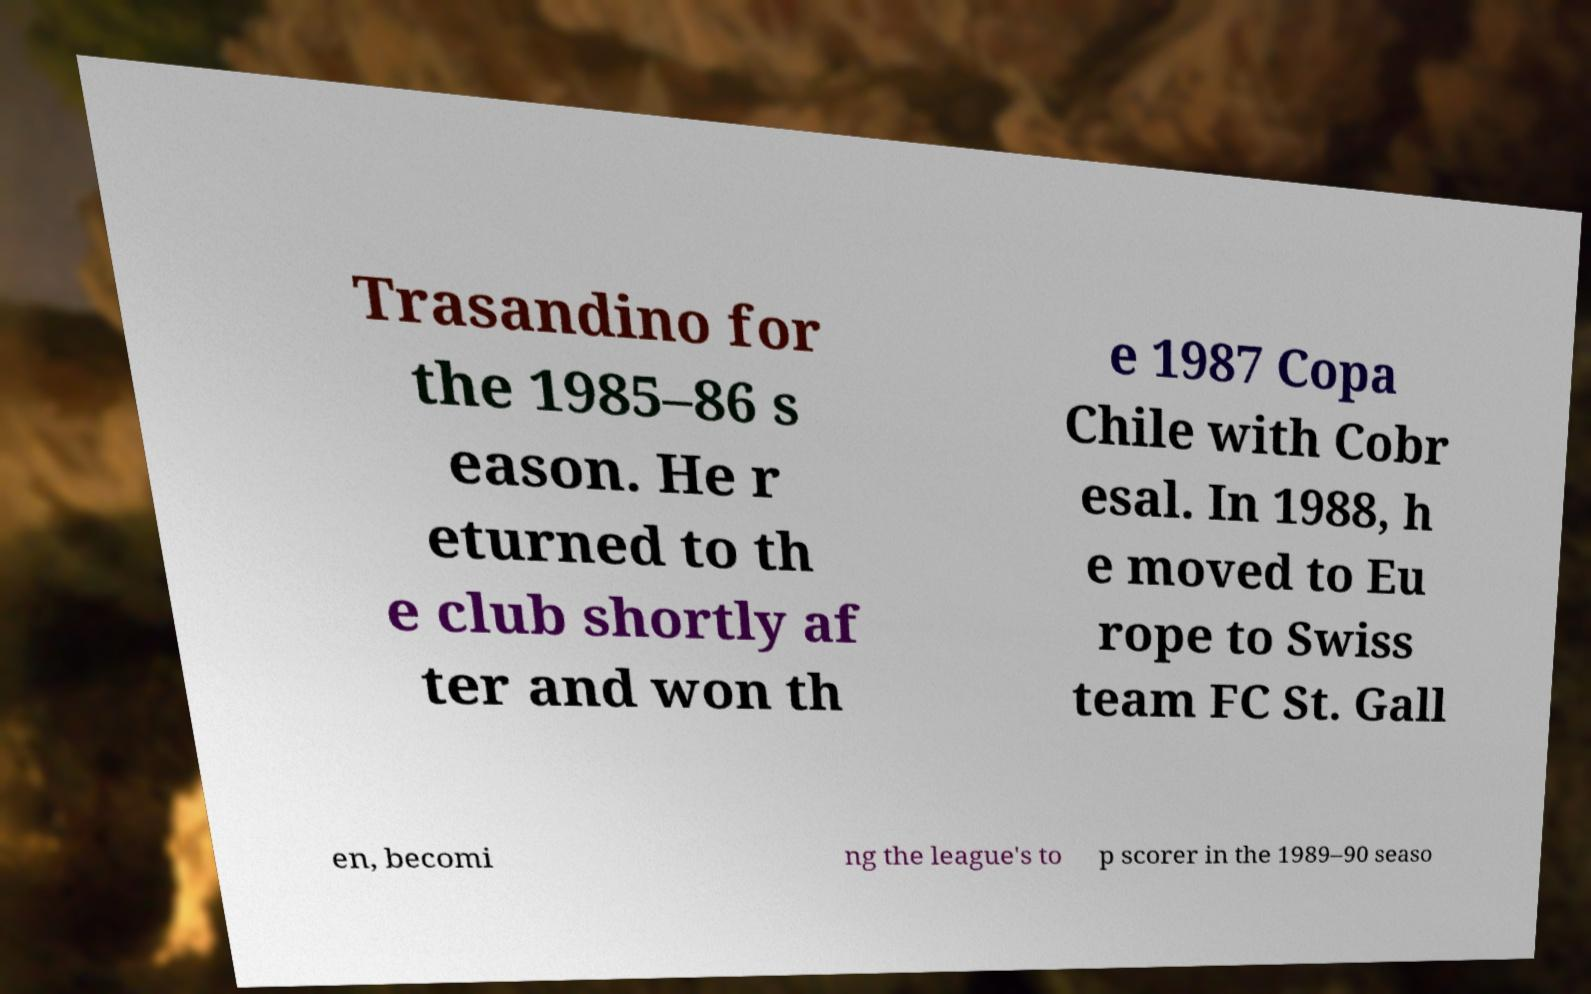Could you assist in decoding the text presented in this image and type it out clearly? Trasandino for the 1985–86 s eason. He r eturned to th e club shortly af ter and won th e 1987 Copa Chile with Cobr esal. In 1988, h e moved to Eu rope to Swiss team FC St. Gall en, becomi ng the league's to p scorer in the 1989–90 seaso 